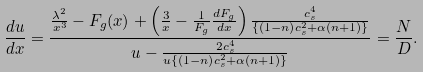<formula> <loc_0><loc_0><loc_500><loc_500>\frac { d u } { d x } = \frac { \frac { \lambda ^ { 2 } } { x ^ { 3 } } - F _ { g } ( x ) + \left ( \frac { 3 } { x } - \frac { 1 } { F _ { g } } \frac { d F _ { g } } { d x } \right ) \frac { c _ { s } ^ { 4 } } { \left \{ \left ( 1 - n \right ) c _ { s } ^ { 2 } + \alpha \left ( n + 1 \right ) \right \} } } { u - \frac { 2 c _ { s } ^ { 4 } } { u \left \{ \left ( 1 - n \right ) c _ { s } ^ { 2 } + \alpha \left ( n + 1 \right ) \right \} } } = \frac { N } { D } .</formula> 